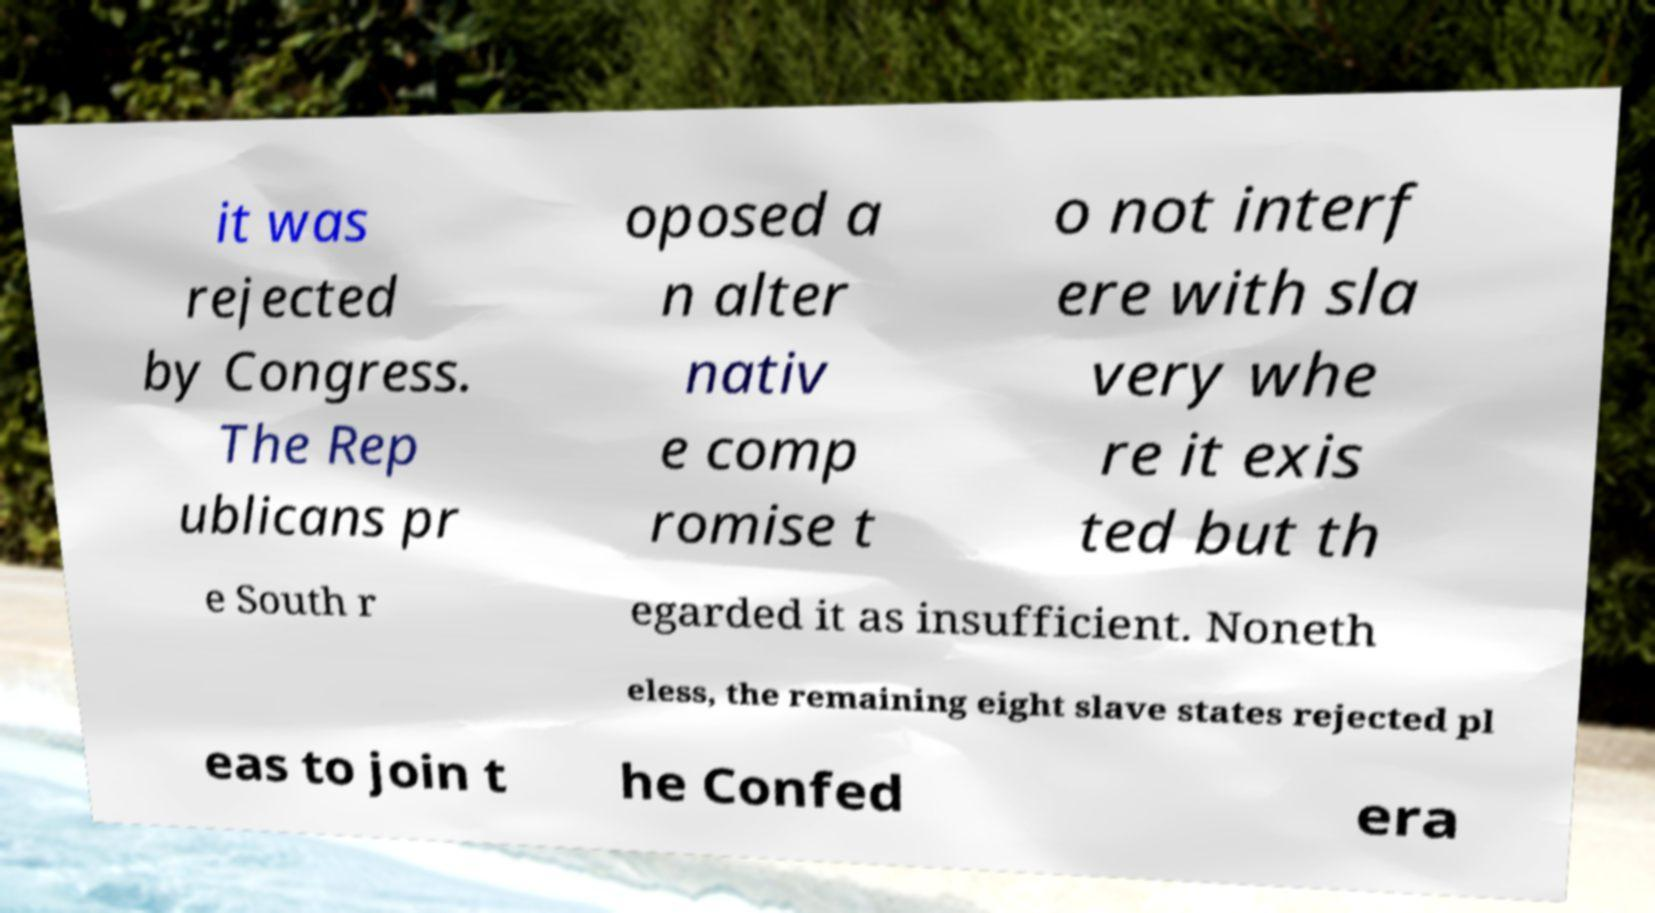Please identify and transcribe the text found in this image. it was rejected by Congress. The Rep ublicans pr oposed a n alter nativ e comp romise t o not interf ere with sla very whe re it exis ted but th e South r egarded it as insufficient. Noneth eless, the remaining eight slave states rejected pl eas to join t he Confed era 